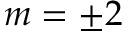Convert formula to latex. <formula><loc_0><loc_0><loc_500><loc_500>m = \pm 2</formula> 